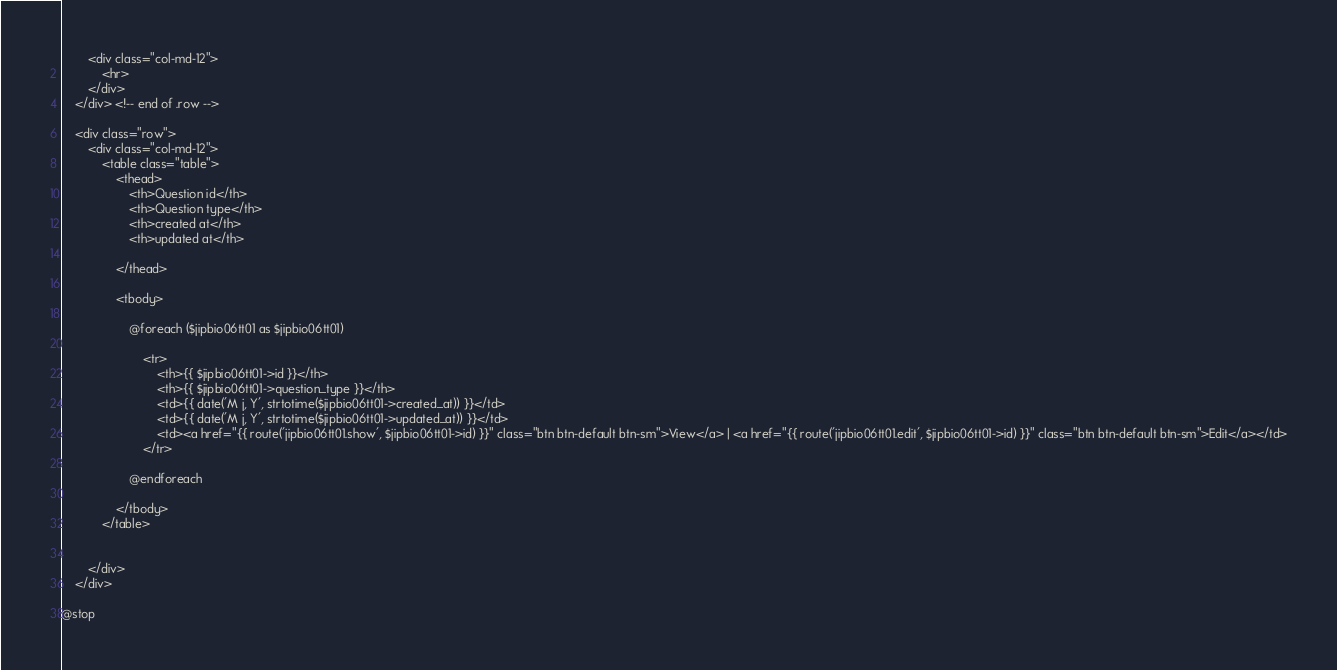<code> <loc_0><loc_0><loc_500><loc_500><_PHP_>		<div class="col-md-12">
			<hr>
		</div>
	</div> <!-- end of .row -->

	<div class="row">
		<div class="col-md-12">
			<table class="table">
				<thead>
					<th>Question id</th>
					<th>Question type</th>
					<th>created at</th>
					<th>updated at</th>

				</thead>

				<tbody>

					@foreach ($jipbio06tt01 as $jipbio06tt01)

						<tr>
                            <th>{{ $jipbio06tt01->id }}</th>
                            <th>{{ $jipbio06tt01->question_type }}</th>
                            <td>{{ date('M j, Y', strtotime($jipbio06tt01->created_at)) }}</td>
                            <td>{{ date('M j, Y', strtotime($jipbio06tt01->updated_at)) }}</td>
							<td><a href="{{ route('jipbio06tt01.show', $jipbio06tt01->id) }}" class="btn btn-default btn-sm">View</a> | <a href="{{ route('jipbio06tt01.edit', $jipbio06tt01->id) }}" class="btn btn-default btn-sm">Edit</a></td>
						</tr>

					@endforeach

				</tbody>
			</table>


		</div>
	</div>

@stop
</code> 